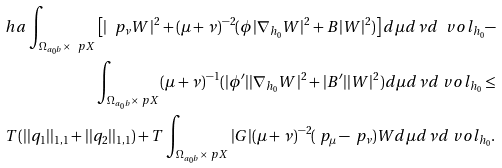<formula> <loc_0><loc_0><loc_500><loc_500>\ h a \int _ { \Omega _ { a _ { 0 } b } \times \ p X } \left [ | \ p _ { \nu } W | ^ { 2 } + ( \mu + \nu ) ^ { - 2 } ( \phi | \nabla _ { h _ { 0 } } W | ^ { 2 } + B | W | ^ { 2 } ) \right ] d \mu d \nu d \ v o l _ { h _ { 0 } } - \\ \int _ { \Omega _ { a _ { 0 } b } \times \ p X } ( \mu + \nu ) ^ { - 1 } ( | \phi ^ { \prime } | | \nabla _ { h _ { 0 } } W | ^ { 2 } + | B ^ { \prime } | | W | ^ { 2 } ) d \mu d \nu d \ v o l _ { h _ { 0 } } \leq \\ T ( | | q _ { 1 } | | _ { 1 , 1 } + | | q _ { 2 } | | _ { 1 , 1 } ) + T \int _ { \Omega _ { a _ { 0 } b } \times \ p X } | G | ( \mu + \nu ) ^ { - 2 } ( \ p _ { \mu } - \ p _ { \nu } ) W d \mu d \nu d \ v o l _ { h _ { 0 } } .</formula> 